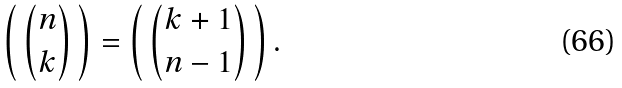Convert formula to latex. <formula><loc_0><loc_0><loc_500><loc_500>\left ( \, { \binom { n } { k } } \, \right ) = \left ( \, { \binom { k + 1 } { n - 1 } } \, \right ) .</formula> 